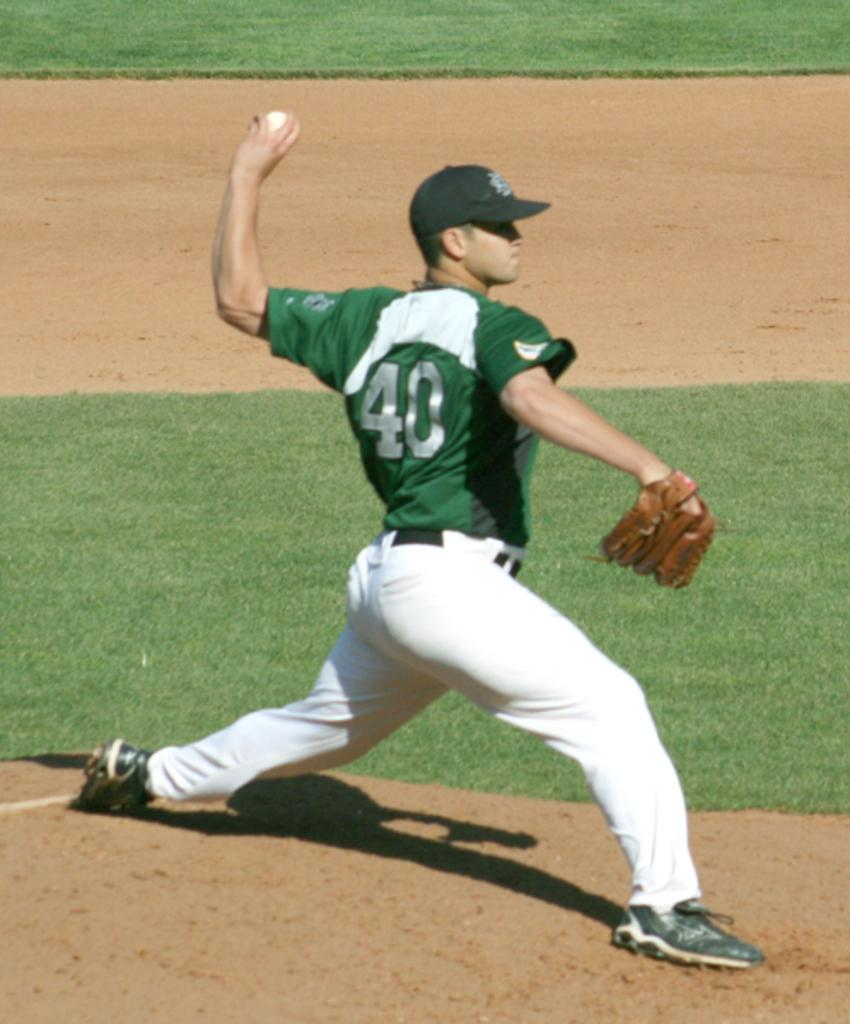<image>
Create a compact narrative representing the image presented. A baseball player wearing jersey number 40 is pitching the ball. 